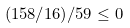Convert formula to latex. <formula><loc_0><loc_0><loc_500><loc_500>( 1 5 8 / 1 6 ) / 5 9 \leq 0</formula> 